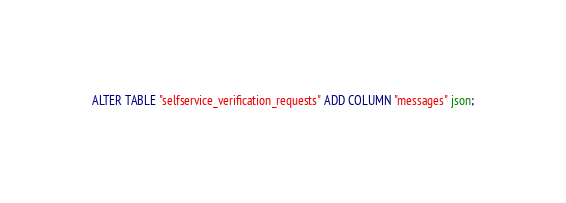Convert code to text. <code><loc_0><loc_0><loc_500><loc_500><_SQL_>ALTER TABLE "selfservice_verification_requests" ADD COLUMN "messages" json;</code> 